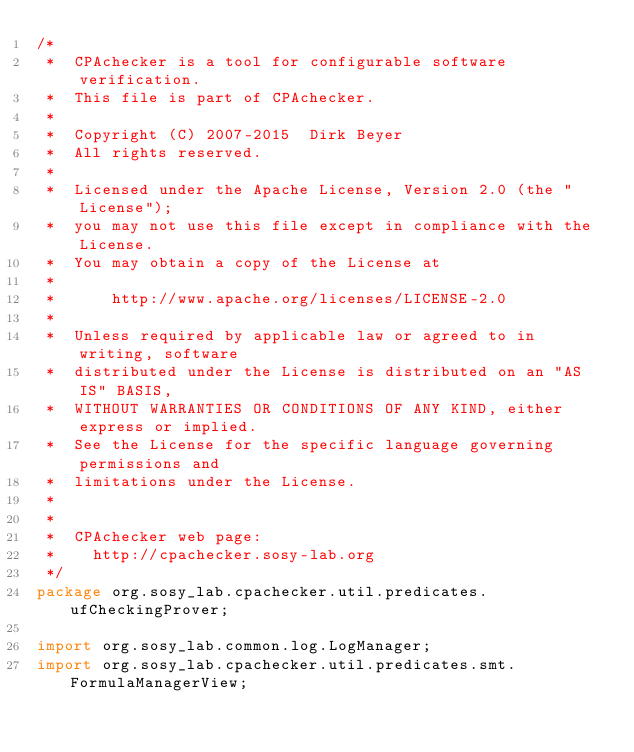Convert code to text. <code><loc_0><loc_0><loc_500><loc_500><_Java_>/*
 *  CPAchecker is a tool for configurable software verification.
 *  This file is part of CPAchecker.
 *
 *  Copyright (C) 2007-2015  Dirk Beyer
 *  All rights reserved.
 *
 *  Licensed under the Apache License, Version 2.0 (the "License");
 *  you may not use this file except in compliance with the License.
 *  You may obtain a copy of the License at
 *
 *      http://www.apache.org/licenses/LICENSE-2.0
 *
 *  Unless required by applicable law or agreed to in writing, software
 *  distributed under the License is distributed on an "AS IS" BASIS,
 *  WITHOUT WARRANTIES OR CONDITIONS OF ANY KIND, either express or implied.
 *  See the License for the specific language governing permissions and
 *  limitations under the License.
 *
 *
 *  CPAchecker web page:
 *    http://cpachecker.sosy-lab.org
 */
package org.sosy_lab.cpachecker.util.predicates.ufCheckingProver;

import org.sosy_lab.common.log.LogManager;
import org.sosy_lab.cpachecker.util.predicates.smt.FormulaManagerView;</code> 